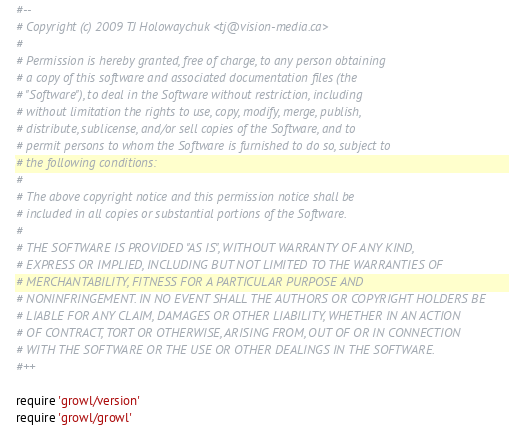Convert code to text. <code><loc_0><loc_0><loc_500><loc_500><_Ruby_>#--
# Copyright (c) 2009 TJ Holowaychuk <tj@vision-media.ca>
#
# Permission is hereby granted, free of charge, to any person obtaining
# a copy of this software and associated documentation files (the
# "Software"), to deal in the Software without restriction, including
# without limitation the rights to use, copy, modify, merge, publish,
# distribute, sublicense, and/or sell copies of the Software, and to
# permit persons to whom the Software is furnished to do so, subject to
# the following conditions:
#
# The above copyright notice and this permission notice shall be
# included in all copies or substantial portions of the Software.
#
# THE SOFTWARE IS PROVIDED "AS IS", WITHOUT WARRANTY OF ANY KIND,
# EXPRESS OR IMPLIED, INCLUDING BUT NOT LIMITED TO THE WARRANTIES OF
# MERCHANTABILITY, FITNESS FOR A PARTICULAR PURPOSE AND
# NONINFRINGEMENT. IN NO EVENT SHALL THE AUTHORS OR COPYRIGHT HOLDERS BE
# LIABLE FOR ANY CLAIM, DAMAGES OR OTHER LIABILITY, WHETHER IN AN ACTION
# OF CONTRACT, TORT OR OTHERWISE, ARISING FROM, OUT OF OR IN CONNECTION
# WITH THE SOFTWARE OR THE USE OR OTHER DEALINGS IN THE SOFTWARE.
#++

require 'growl/version'
require 'growl/growl'</code> 